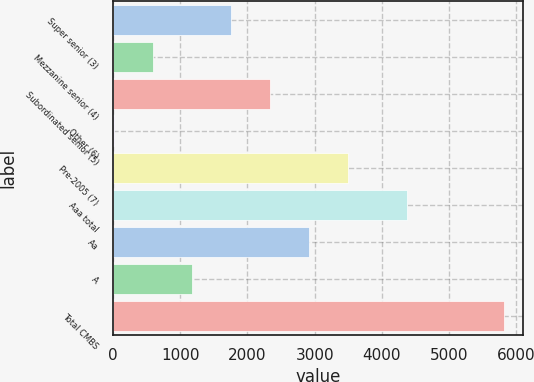Convert chart. <chart><loc_0><loc_0><loc_500><loc_500><bar_chart><fcel>Super senior (3)<fcel>Mezzanine senior (4)<fcel>Subordinated senior (5)<fcel>Other (6)<fcel>Pre-2005 (7)<fcel>Aaa total<fcel>Aa<fcel>A<fcel>Total CMBS<nl><fcel>1759.9<fcel>601.3<fcel>2339.2<fcel>22<fcel>3497.8<fcel>4368<fcel>2918.5<fcel>1180.6<fcel>5815<nl></chart> 